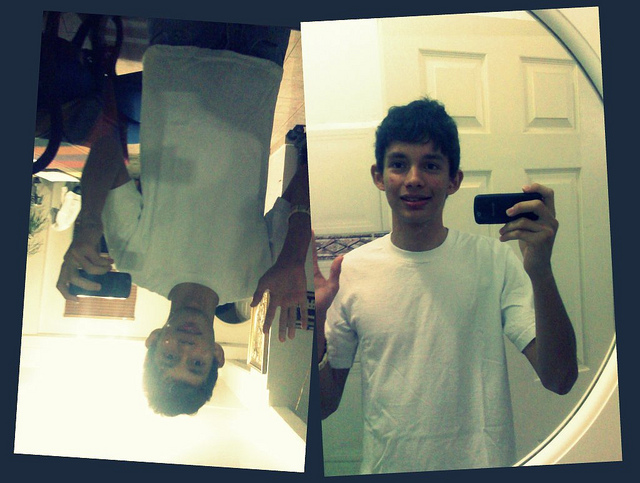Can you describe any emotions or expressions on the person's face? The individual appears to have a neutral to slight smiling expression. Emotions can be subjective, but based on the visual content, the person seems to be in a neutral or mildly happy state. 